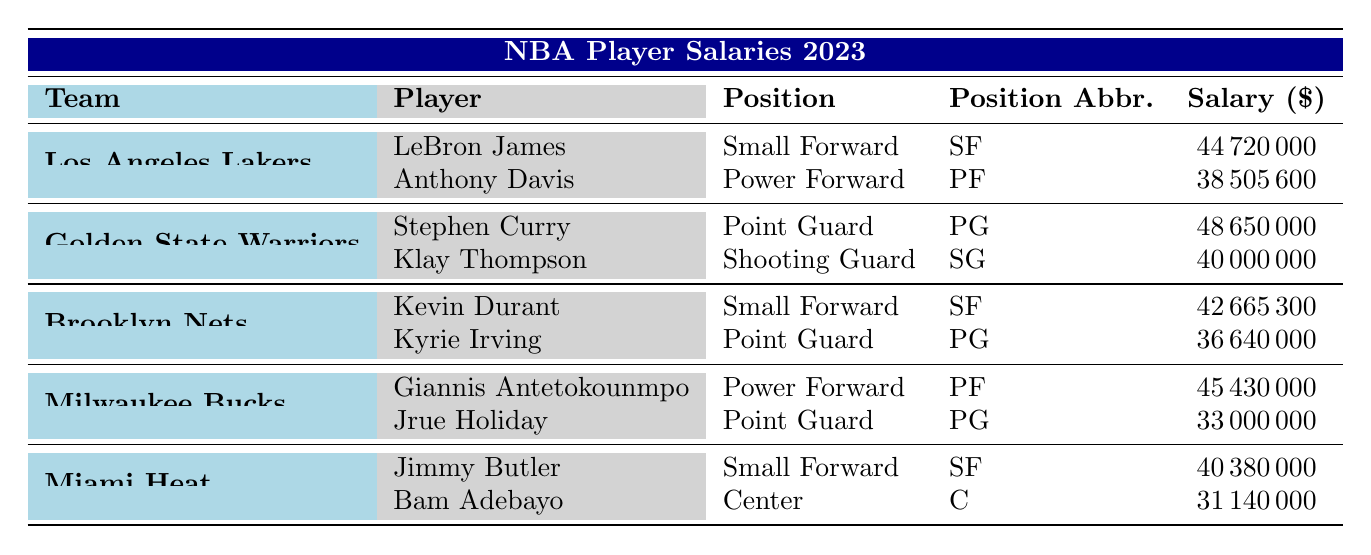What is the highest salary among the players listed? By reviewing the salary column for each player, we see that Stephen Curry has the highest salary of 48650000.
Answer: 48650000 Which team has the player with the lowest salary? Looking at the salaries, Jrue Holiday has the lowest salary of 33000000, which belongs to the Milwaukee Bucks.
Answer: Milwaukee Bucks What is the average salary of the players from the Golden State Warriors? The salaries for the players from the Golden State Warriors are 48650000 and 40000000. The sum is 48650000 + 40000000 = 88650000. Dividing by the number of players (2), the average is 88650000 / 2 = 44325000.
Answer: 44325000 Do the Brooklyn Nets have any players earning more than 40000000? Kevin Durant earns 42665300 and Kyrie Irving earns 36640000. Since only Kevin Durant exceeds 40000000, the answer is yes.
Answer: Yes What is the total salary of all players from the Los Angeles Lakers? The salaries for the Los Angeles Lakers are 44720000 and 38505600. Adding these gives a total of 44720000 + 38505600 = 83225600.
Answer: 83225600 Which position is most commonly represented in this table? By counting the positions listed in the table, Small Forwards appear 3 times, Point Guards appear 3 times, Power Forwards appear 2 times, Shooting Guards appear 1 time, and Centers appear 1 time. Both Small Forward and Point Guard have equal representation, so they are both tied for the most common position.
Answer: Small Forward and Point Guard Is Anthony Davis' salary greater than Jimmy Butler's salary? Anthony Davis earns 38505600 while Jimmy Butler earns 40380000. Since 38505600 is less than 40380000, the answer is no.
Answer: No 